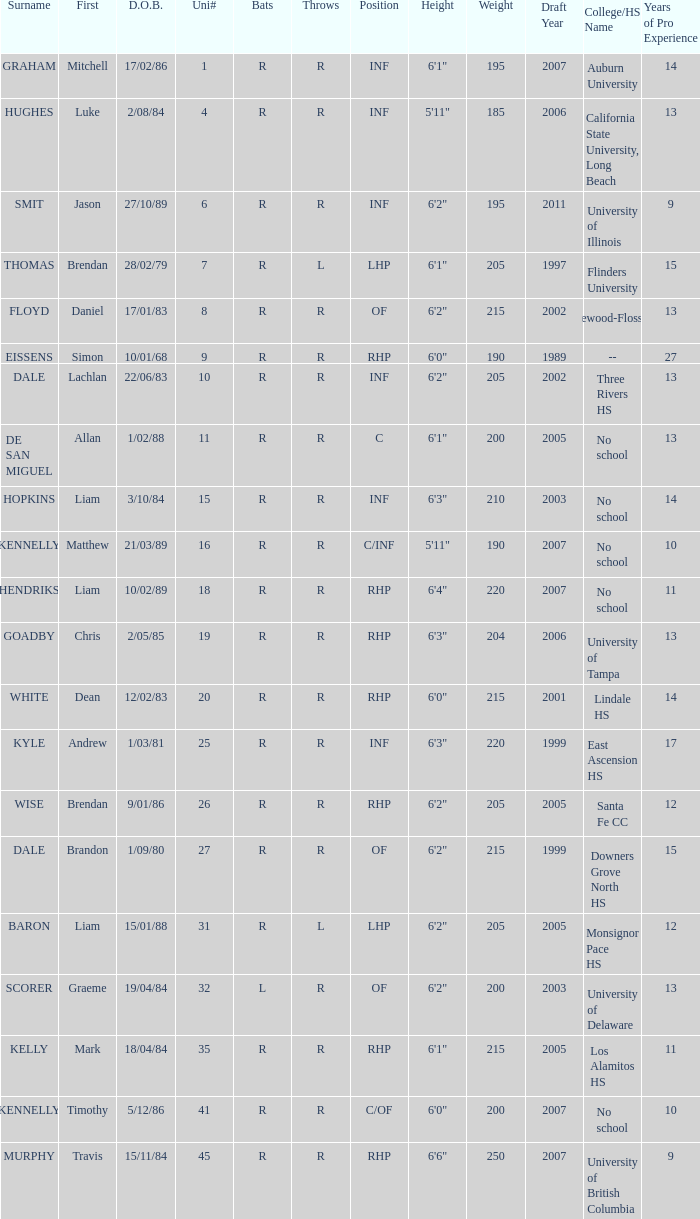Which participant has a last name of baron? R. 